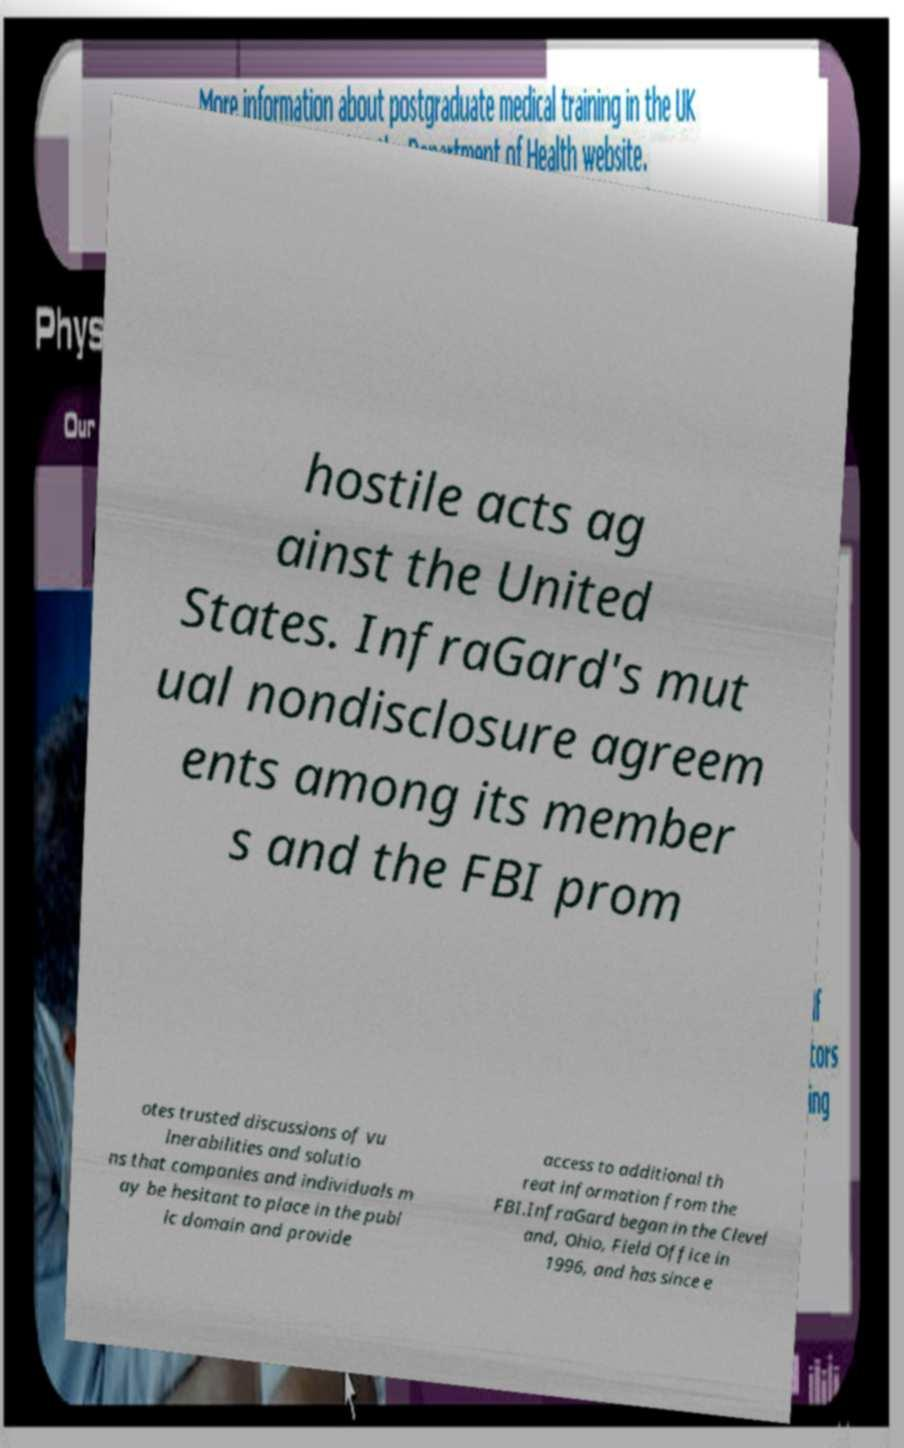Please identify and transcribe the text found in this image. hostile acts ag ainst the United States. InfraGard's mut ual nondisclosure agreem ents among its member s and the FBI prom otes trusted discussions of vu lnerabilities and solutio ns that companies and individuals m ay be hesitant to place in the publ ic domain and provide access to additional th reat information from the FBI.InfraGard began in the Clevel and, Ohio, Field Office in 1996, and has since e 